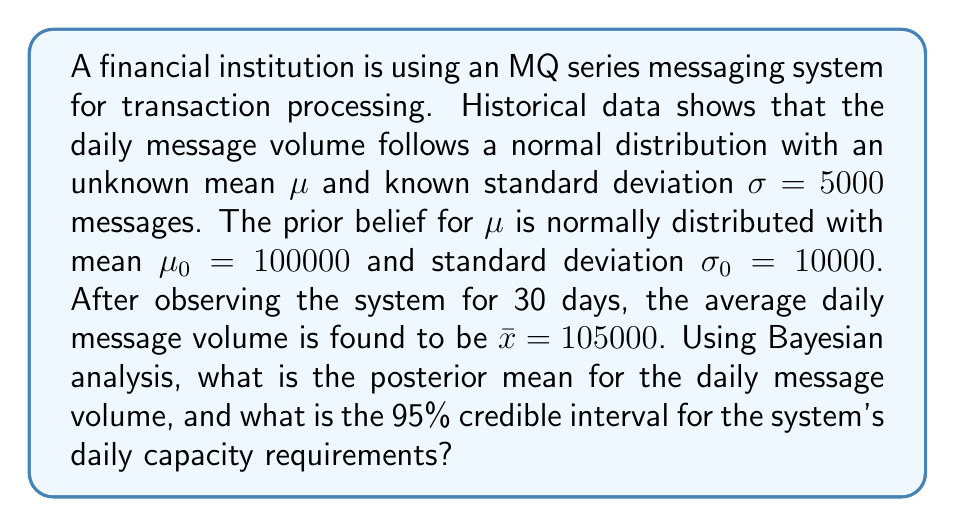Help me with this question. To solve this problem, we'll use Bayesian updating for a normal distribution with known variance. The steps are as follows:

1) First, we need to calculate the posterior mean $\mu_n$ using the formula:

   $$\mu_n = \frac{\frac{\mu_0}{\sigma_0^2} + \frac{n\bar{x}}{\sigma^2}}{\frac{1}{\sigma_0^2} + \frac{n}{\sigma^2}}$$

   Where:
   $\mu_0 = 100000$ (prior mean)
   $\sigma_0 = 10000$ (prior standard deviation)
   $\bar{x} = 105000$ (sample mean)
   $\sigma = 5000$ (known standard deviation of the distribution)
   $n = 30$ (number of days observed)

2) Substituting these values:

   $$\mu_n = \frac{\frac{100000}{10000^2} + \frac{30 \cdot 105000}{5000^2}}{\frac{1}{10000^2} + \frac{30}{5000^2}}$$

3) Simplifying:

   $$\mu_n = \frac{0.001 + 0.126}{0.00000001 + 0.0000012} = \frac{0.127}{0.00000121} \approx 104958.68$$

4) Next, we need to calculate the posterior standard deviation $\sigma_n$ using the formula:

   $$\sigma_n^2 = \frac{1}{\frac{1}{\sigma_0^2} + \frac{n}{\sigma^2}}$$

5) Substituting the values:

   $$\sigma_n^2 = \frac{1}{\frac{1}{10000^2} + \frac{30}{5000^2}} = \frac{1}{0.00000121} \approx 826446.28$$

6) Taking the square root:

   $$\sigma_n = \sqrt{826446.28} \approx 909.09$$

7) For a 95% credible interval, we use the formula:

   $$[\mu_n - 1.96\sigma_n, \mu_n + 1.96\sigma_n]$$

8) Substituting our calculated values:

   $$[104958.68 - 1.96 \cdot 909.09, 104958.68 + 1.96 \cdot 909.09]$$

9) Calculating:

   $$[103176.86, 106740.50]$$
Answer: The posterior mean for the daily message volume is approximately 104,959 messages. The 95% credible interval for the system's daily capacity requirements is approximately [103,177, 106,741] messages. 